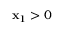<formula> <loc_0><loc_0><loc_500><loc_500>x _ { 1 } > 0</formula> 